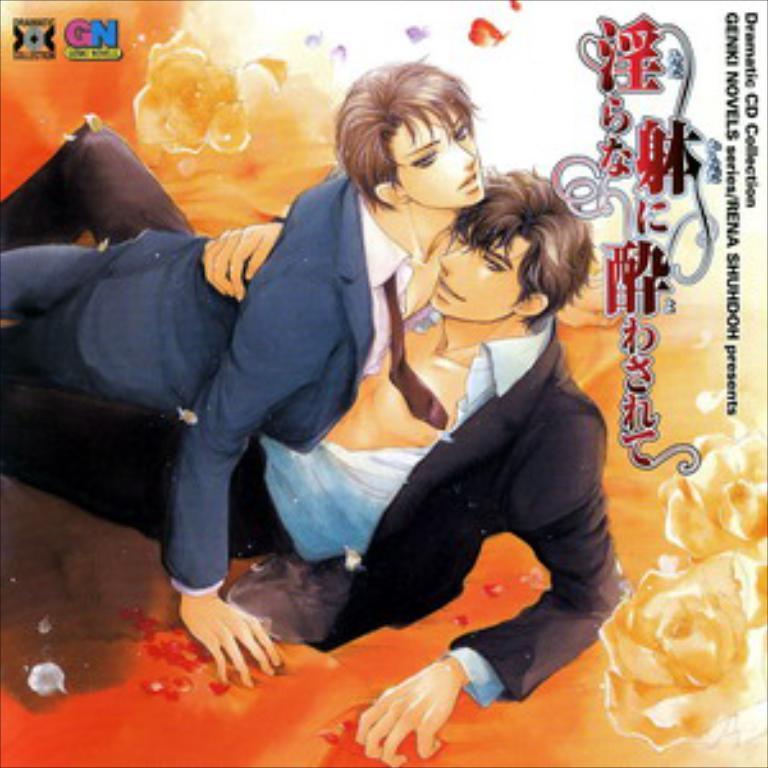What type of visual is the image? The image is a poster. How many people are depicted in the poster? There are two persons in the poster. Is there any text present in the poster? Yes, there is text in the poster. Where is the sink located in the poster? There is no sink present in the poster. What type of arithmetic problem is being solved by the persons in the poster? There is no arithmetic problem depicted in the poster. 